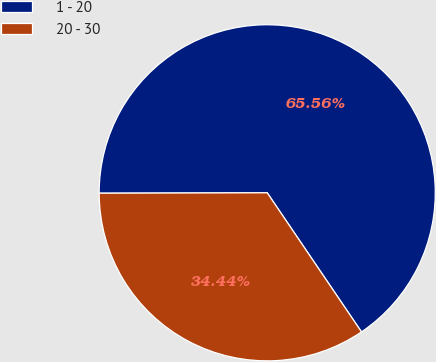<chart> <loc_0><loc_0><loc_500><loc_500><pie_chart><fcel>1 - 20<fcel>20 - 30<nl><fcel>65.56%<fcel>34.44%<nl></chart> 